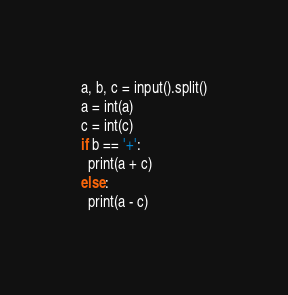<code> <loc_0><loc_0><loc_500><loc_500><_Python_>a, b, c = input().split()
a = int(a)
c = int(c)
if b == '+':
  print(a + c)
else:
  print(a - c)</code> 